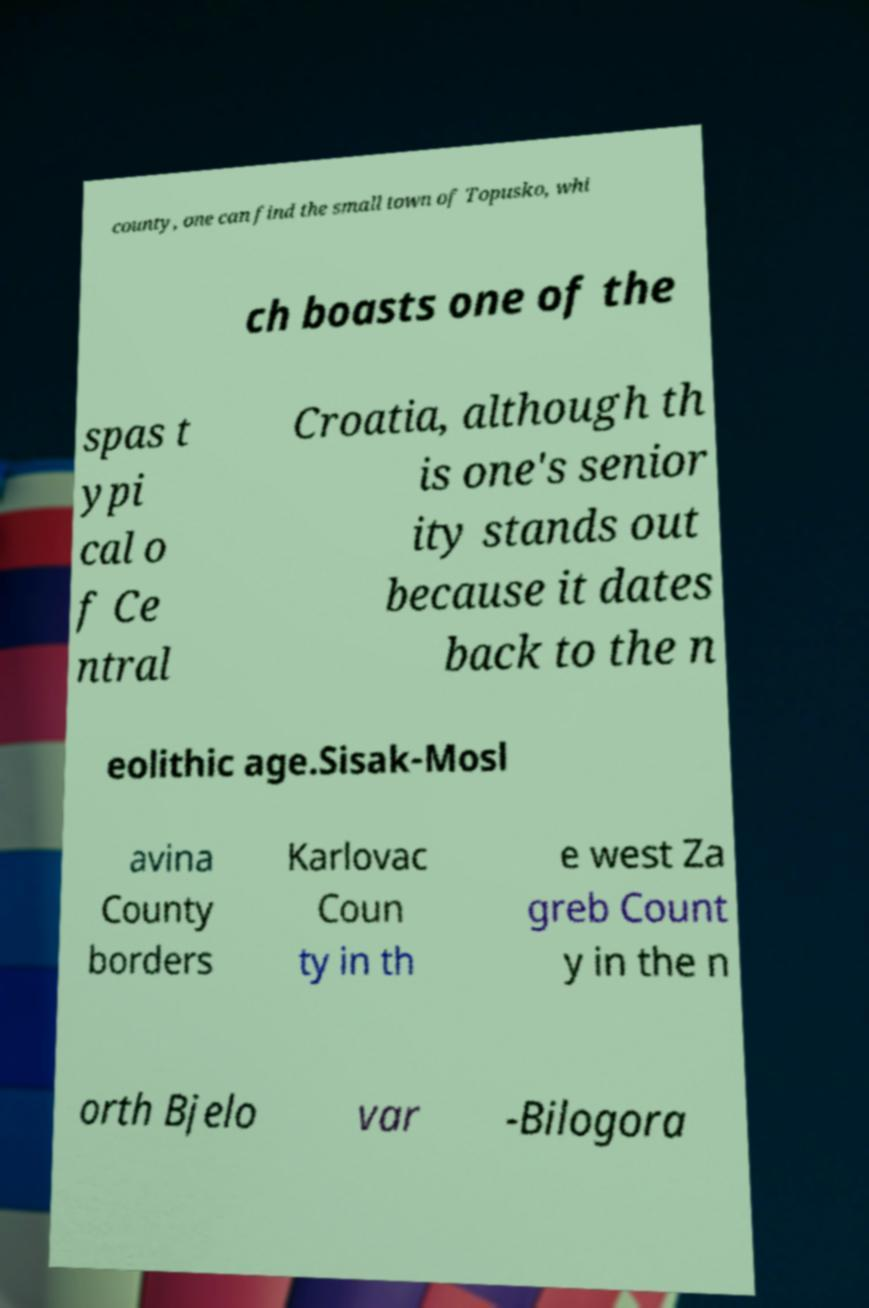Can you read and provide the text displayed in the image?This photo seems to have some interesting text. Can you extract and type it out for me? county, one can find the small town of Topusko, whi ch boasts one of the spas t ypi cal o f Ce ntral Croatia, although th is one's senior ity stands out because it dates back to the n eolithic age.Sisak-Mosl avina County borders Karlovac Coun ty in th e west Za greb Count y in the n orth Bjelo var -Bilogora 